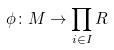<formula> <loc_0><loc_0><loc_500><loc_500>\phi \colon M \rightarrow \prod _ { i \in I } R</formula> 